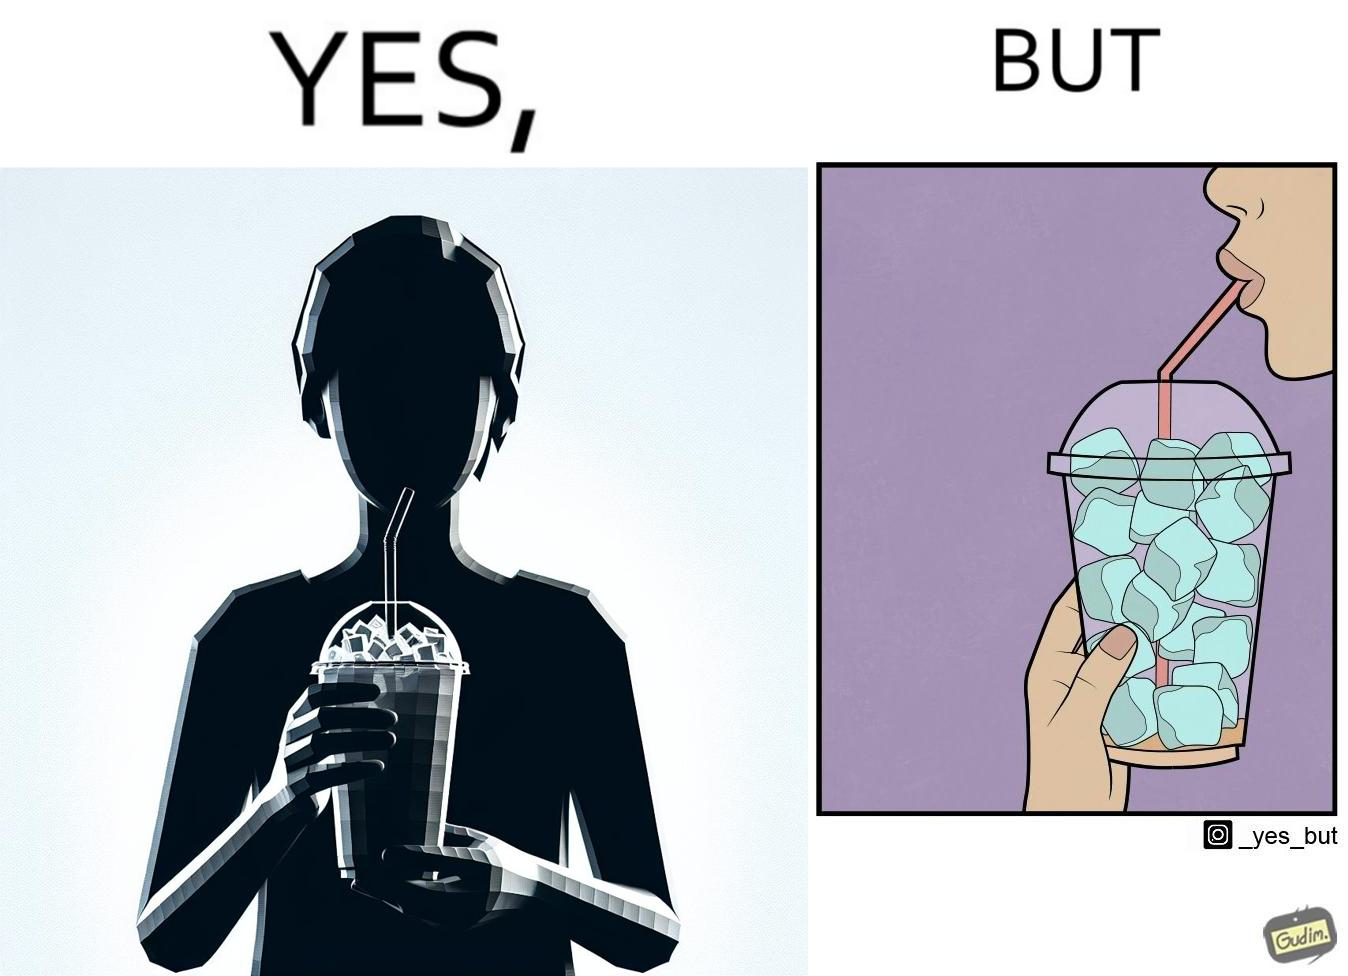Why is this image considered satirical? The image is funny, as the drink seems to be full to begin with, while most of the volume of the drink is occupied by the ice cubes. 